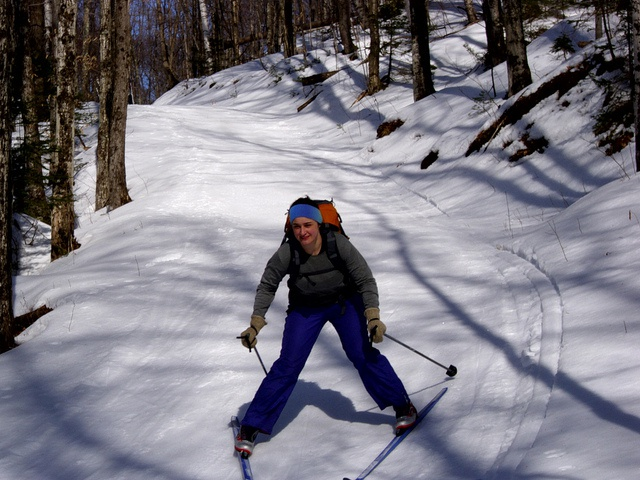Describe the objects in this image and their specific colors. I can see people in black, navy, darkgray, and gray tones, skis in black, darkgray, gray, and navy tones, and backpack in black, maroon, and darkgray tones in this image. 